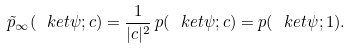<formula> <loc_0><loc_0><loc_500><loc_500>\tilde { p } _ { \infty } ( \ k e t { \psi } ; c ) = \frac { 1 } { | c | ^ { 2 } } \, p ( \ k e t { \psi } ; c ) = p ( \ k e t { \psi } ; 1 ) .</formula> 